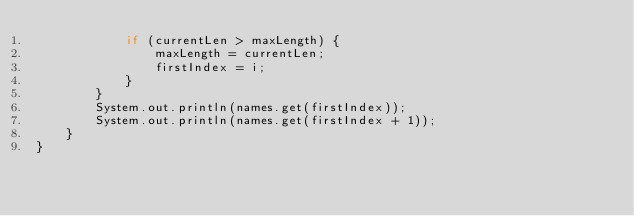<code> <loc_0><loc_0><loc_500><loc_500><_Java_>            if (currentLen > maxLength) {
                maxLength = currentLen;
                firstIndex = i;
            }
        }
        System.out.println(names.get(firstIndex));
        System.out.println(names.get(firstIndex + 1));
    }
}
</code> 